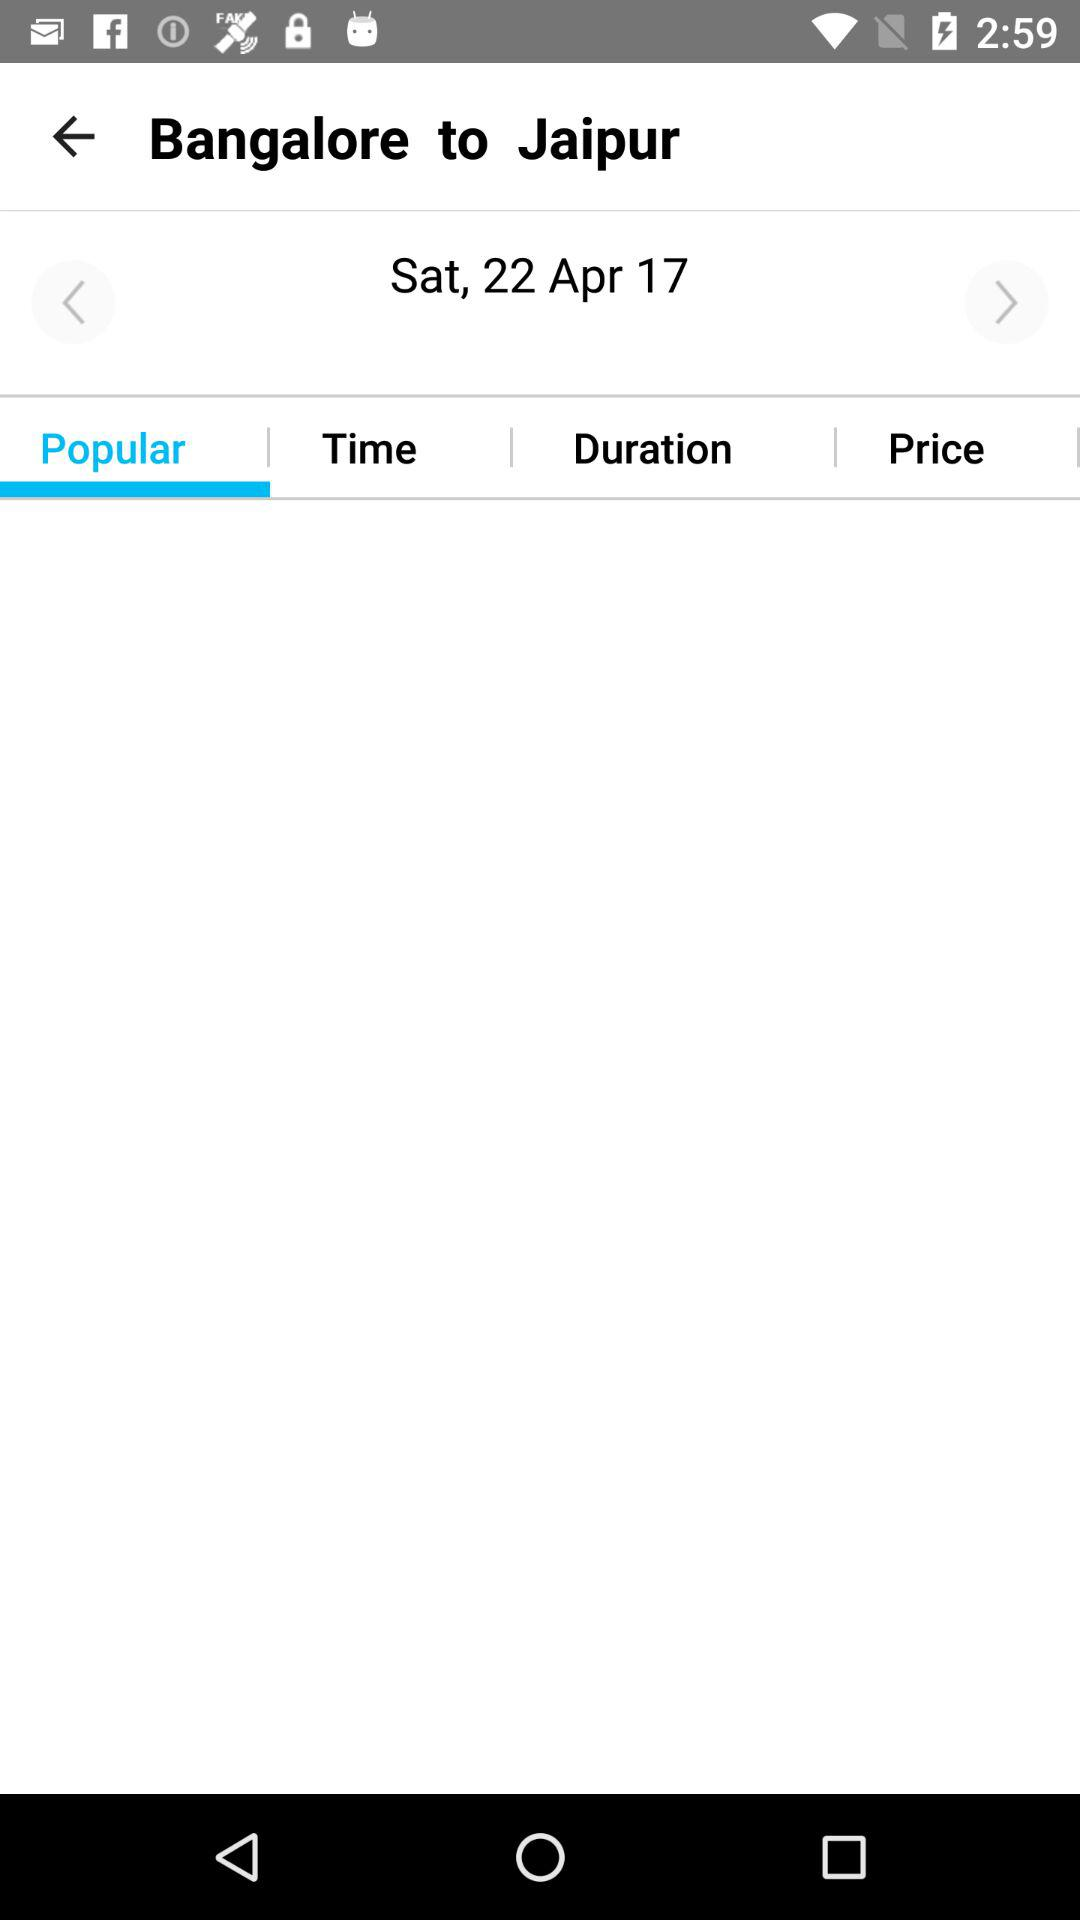What is the mode of transportation?
When the provided information is insufficient, respond with <no answer>. <no answer> 